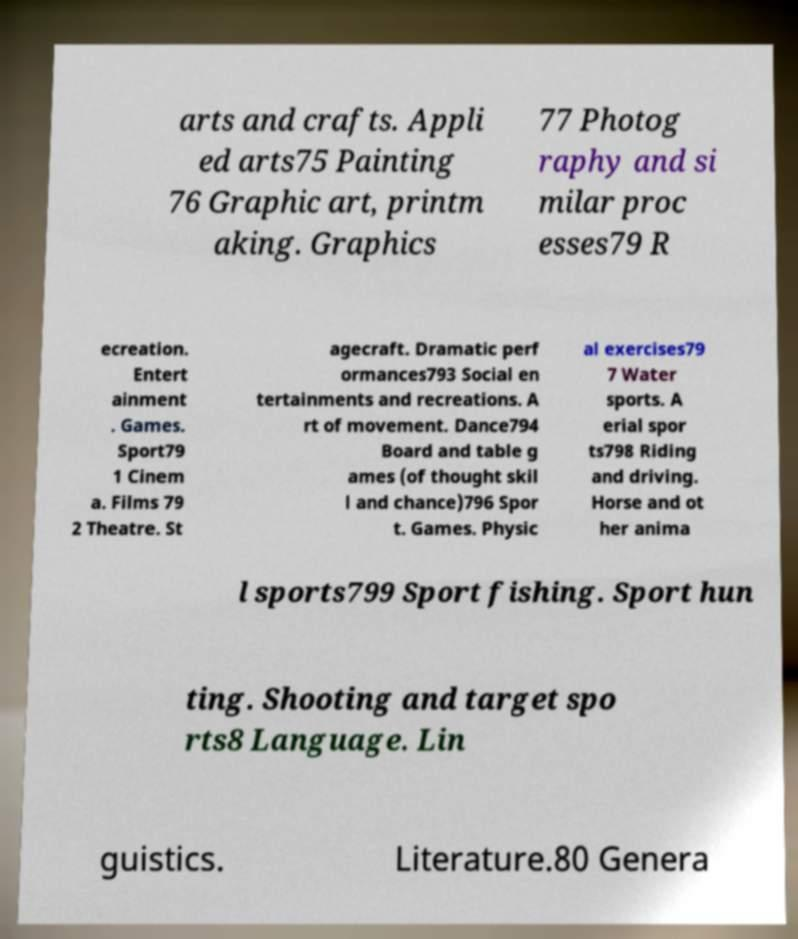Can you read and provide the text displayed in the image?This photo seems to have some interesting text. Can you extract and type it out for me? arts and crafts. Appli ed arts75 Painting 76 Graphic art, printm aking. Graphics 77 Photog raphy and si milar proc esses79 R ecreation. Entert ainment . Games. Sport79 1 Cinem a. Films 79 2 Theatre. St agecraft. Dramatic perf ormances793 Social en tertainments and recreations. A rt of movement. Dance794 Board and table g ames (of thought skil l and chance)796 Spor t. Games. Physic al exercises79 7 Water sports. A erial spor ts798 Riding and driving. Horse and ot her anima l sports799 Sport fishing. Sport hun ting. Shooting and target spo rts8 Language. Lin guistics. Literature.80 Genera 